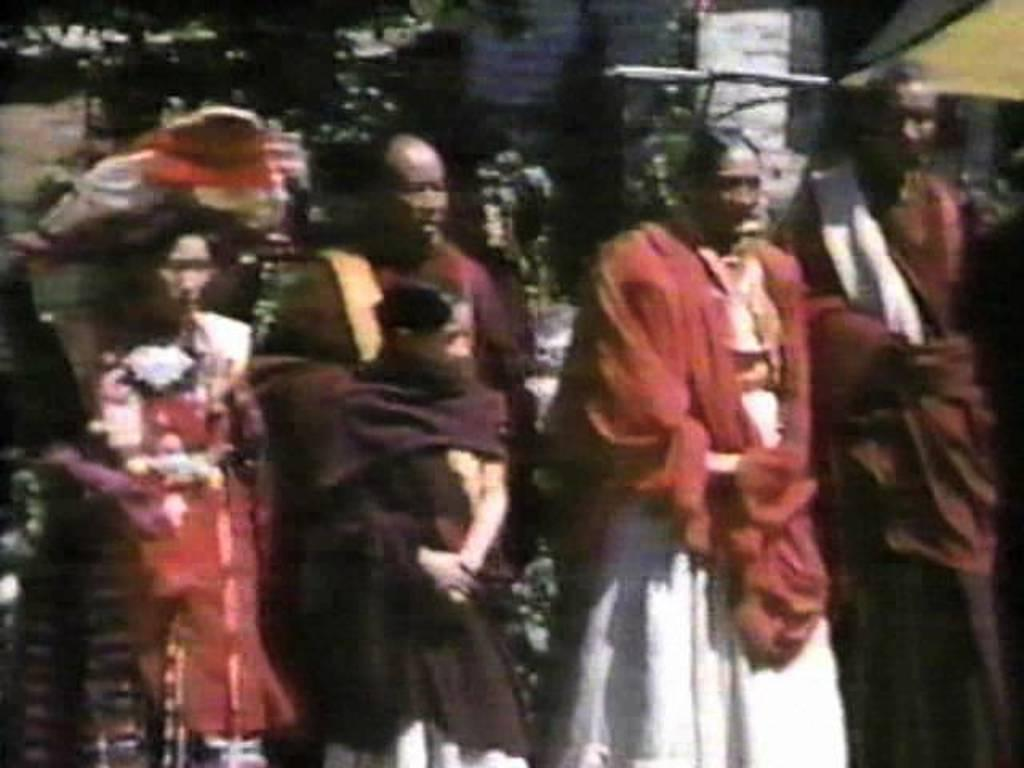How many people are in the group visible in the image? There is a group of people in the image, but the exact number cannot be determined without more specific information. What is visible in the background of the image? There is a building and trees in the background of the image. What type of cattle can be seen grazing in the image? There is no cattle present in the image. How many pigs are visible in the image? There is no pig present in the image. What type of beast is interacting with the people in the image? There is no beast present in the image. 